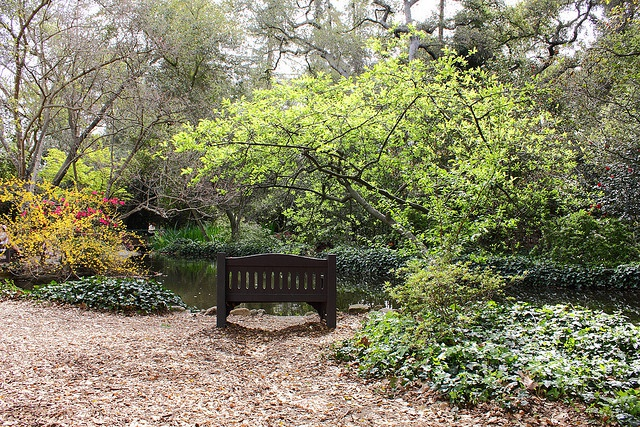Describe the objects in this image and their specific colors. I can see a bench in beige, black, gray, darkgreen, and darkgray tones in this image. 